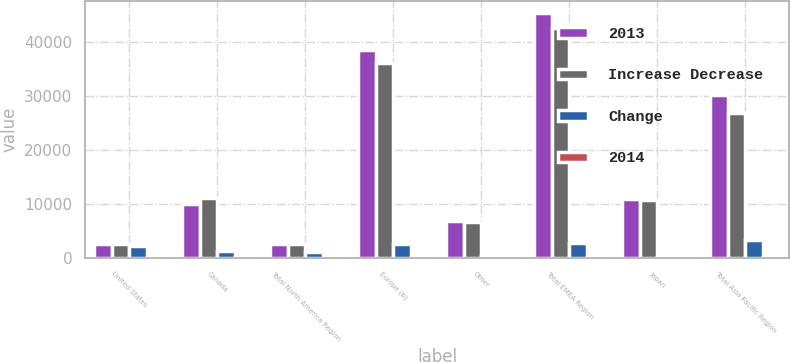<chart> <loc_0><loc_0><loc_500><loc_500><stacked_bar_chart><ecel><fcel>United States<fcel>Canada<fcel>Total North America Region<fcel>Europe (b)<fcel>Other<fcel>Total EMEA Region<fcel>Japan<fcel>Total Asia Pacific Region<nl><fcel>2013<fcel>2564.5<fcel>9871<fcel>2564.5<fcel>38491<fcel>6832<fcel>45323<fcel>10775<fcel>30074<nl><fcel>Increase Decrease<fcel>2564.5<fcel>11062<fcel>2564.5<fcel>36076<fcel>6533<fcel>42609<fcel>10751<fcel>26890<nl><fcel>Change<fcel>2216<fcel>1191<fcel>1025<fcel>2415<fcel>299<fcel>2714<fcel>24<fcel>3184<nl><fcel>2014<fcel>1.3<fcel>10.8<fcel>0.6<fcel>6.7<fcel>4.6<fcel>6.4<fcel>0.2<fcel>11.8<nl></chart> 